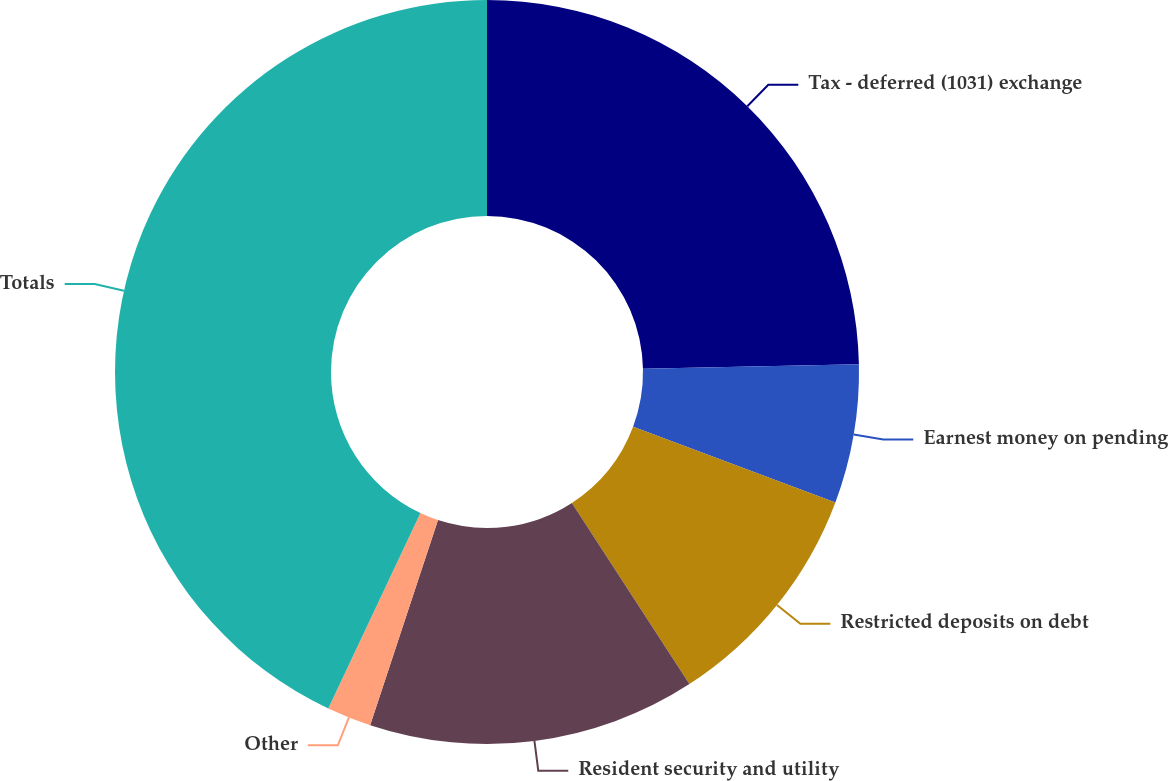Convert chart. <chart><loc_0><loc_0><loc_500><loc_500><pie_chart><fcel>Tax - deferred (1031) exchange<fcel>Earnest money on pending<fcel>Restricted deposits on debt<fcel>Resident security and utility<fcel>Other<fcel>Totals<nl><fcel>24.67%<fcel>6.03%<fcel>10.14%<fcel>14.24%<fcel>1.93%<fcel>42.98%<nl></chart> 